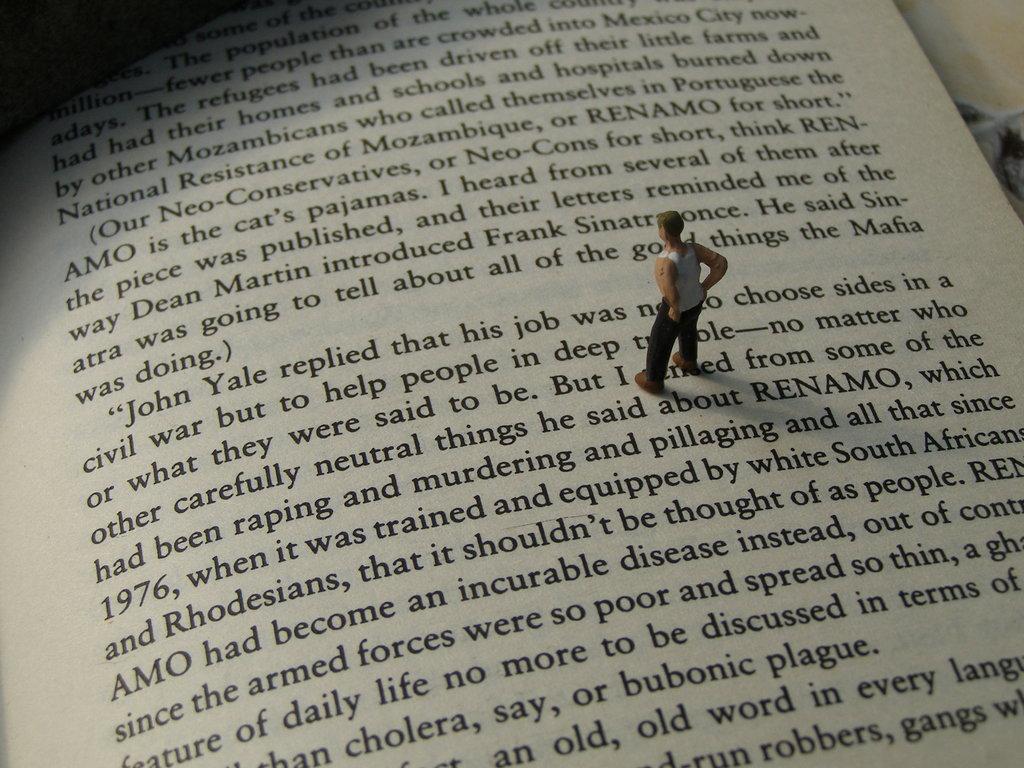Who did dean martin introduce?
Give a very brief answer. Frank sinatra. 